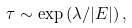Convert formula to latex. <formula><loc_0><loc_0><loc_500><loc_500>\tau \sim \exp \left ( \lambda / | E | \right ) ,</formula> 